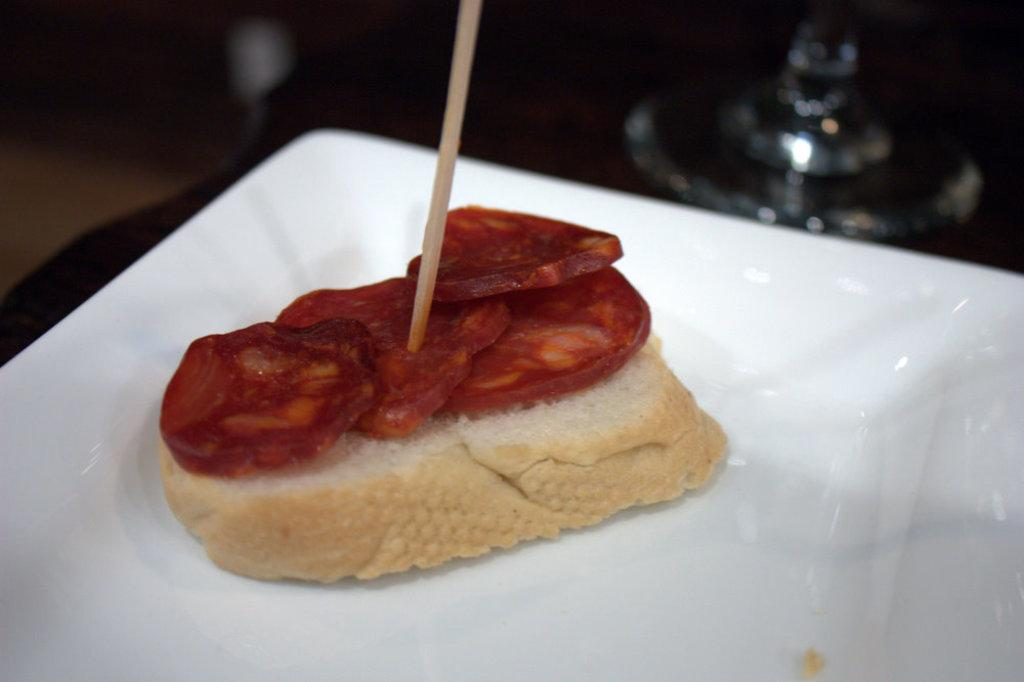What type of food is on the plate in the image? There is a sandwich on a plate in the image. Is there anything inserted into the sandwich? Yes, the sandwich has a toothpick in it. Can you describe the background of the image? The background of the image is blurred. What type of pin can be seen holding the sandwich together in the image? There is no pin present in the image; the sandwich is held together by a toothpick. What advice can be given to the sandwich in the image? The sandwich is an inanimate object and cannot receive or follow advice. 